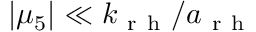<formula> <loc_0><loc_0><loc_500><loc_500>| \mu _ { 5 } | \ll k _ { r h } / a _ { r h }</formula> 